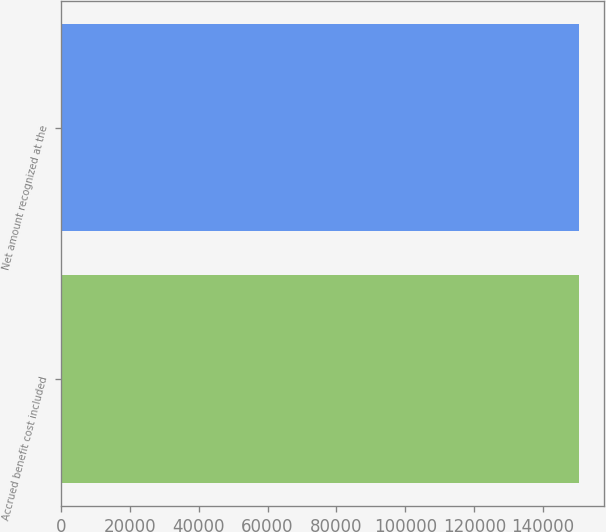Convert chart to OTSL. <chart><loc_0><loc_0><loc_500><loc_500><bar_chart><fcel>Accrued benefit cost included<fcel>Net amount recognized at the<nl><fcel>150257<fcel>150257<nl></chart> 